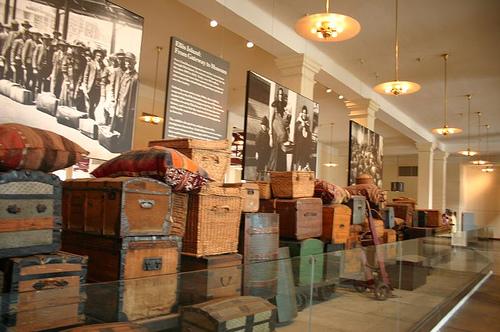Do you see old trunks?
Give a very brief answer. Yes. What is the place called?
Give a very brief answer. Museum. How many hanging lights are there?
Give a very brief answer. 6. 